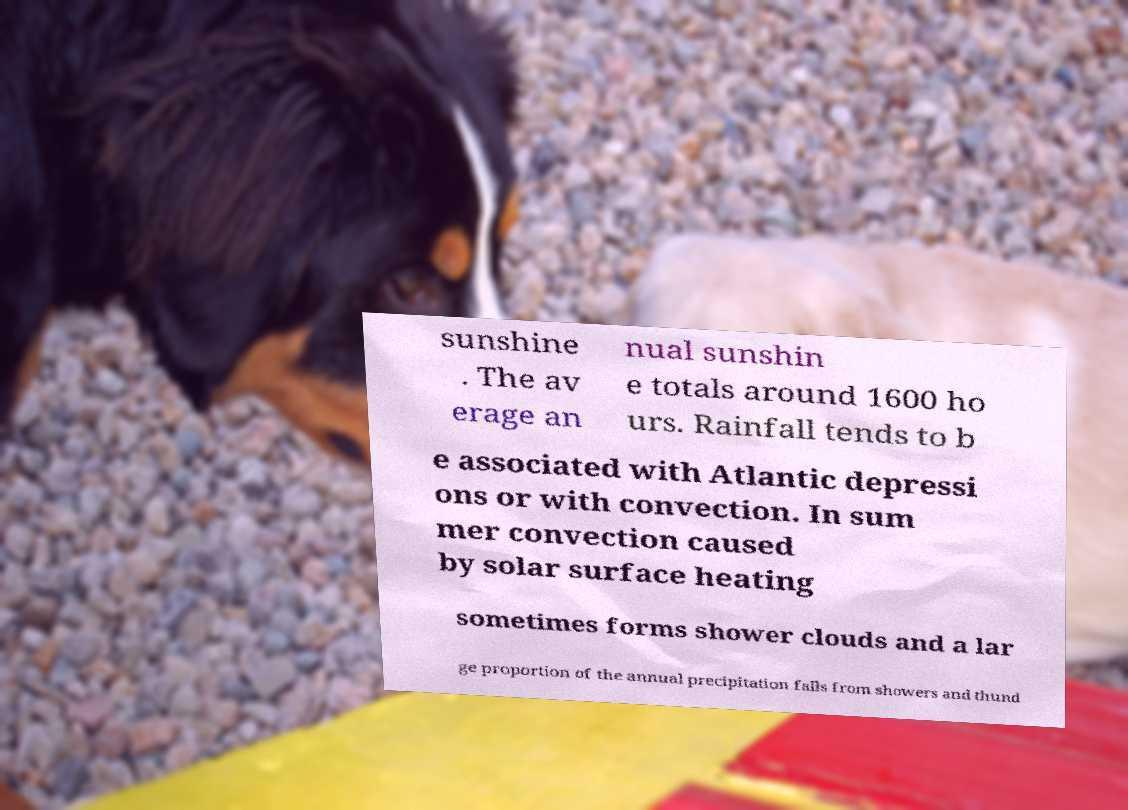Can you read and provide the text displayed in the image?This photo seems to have some interesting text. Can you extract and type it out for me? sunshine . The av erage an nual sunshin e totals around 1600 ho urs. Rainfall tends to b e associated with Atlantic depressi ons or with convection. In sum mer convection caused by solar surface heating sometimes forms shower clouds and a lar ge proportion of the annual precipitation falls from showers and thund 